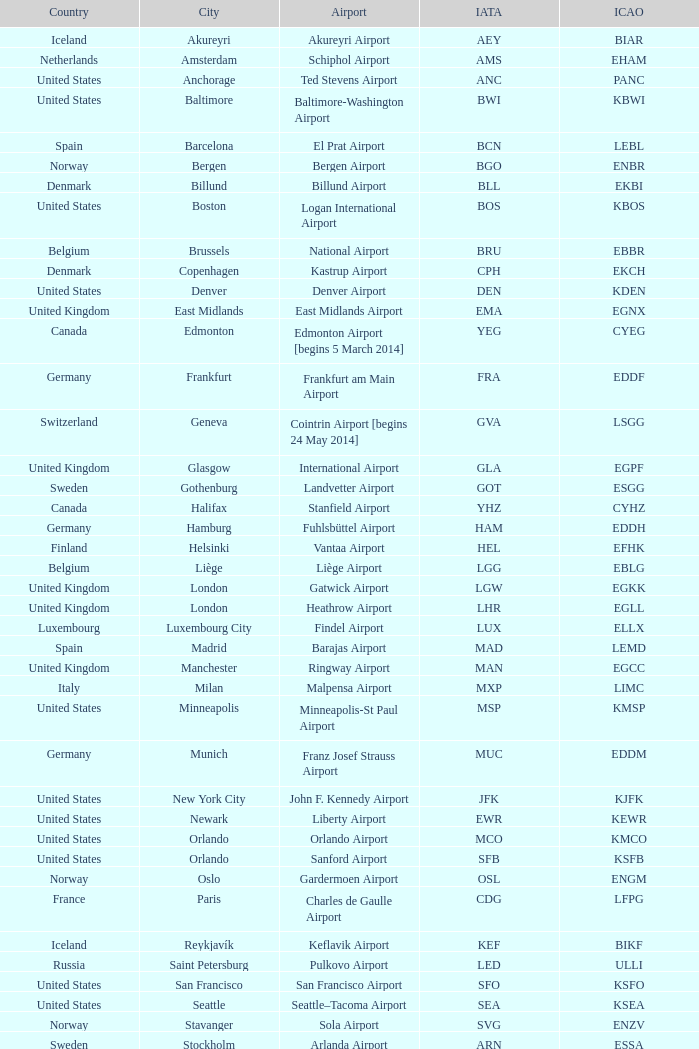What Airport's IATA is SEA? Seattle–Tacoma Airport. 